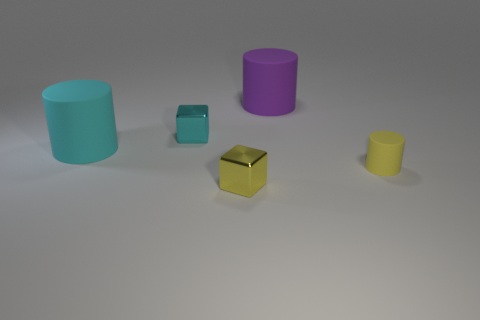Does the cyan block have the same size as the cyan matte object?
Ensure brevity in your answer.  No. There is a cyan object that is the same shape as the big purple matte thing; what is it made of?
Keep it short and to the point. Rubber. Is there anything else that is the same material as the small cyan thing?
Your response must be concise. Yes. How many cyan objects are cylinders or tiny rubber things?
Offer a terse response. 1. What is the tiny block in front of the tiny yellow rubber object made of?
Ensure brevity in your answer.  Metal. Are there more yellow things than brown shiny cylinders?
Give a very brief answer. Yes. There is a metallic thing that is in front of the cyan shiny object; does it have the same shape as the purple thing?
Your answer should be very brief. No. How many rubber cylinders are in front of the cyan block and behind the cyan rubber cylinder?
Ensure brevity in your answer.  0. How many other metallic objects are the same shape as the tiny cyan shiny thing?
Give a very brief answer. 1. What is the color of the cube behind the large matte object that is in front of the large purple matte thing?
Offer a terse response. Cyan. 